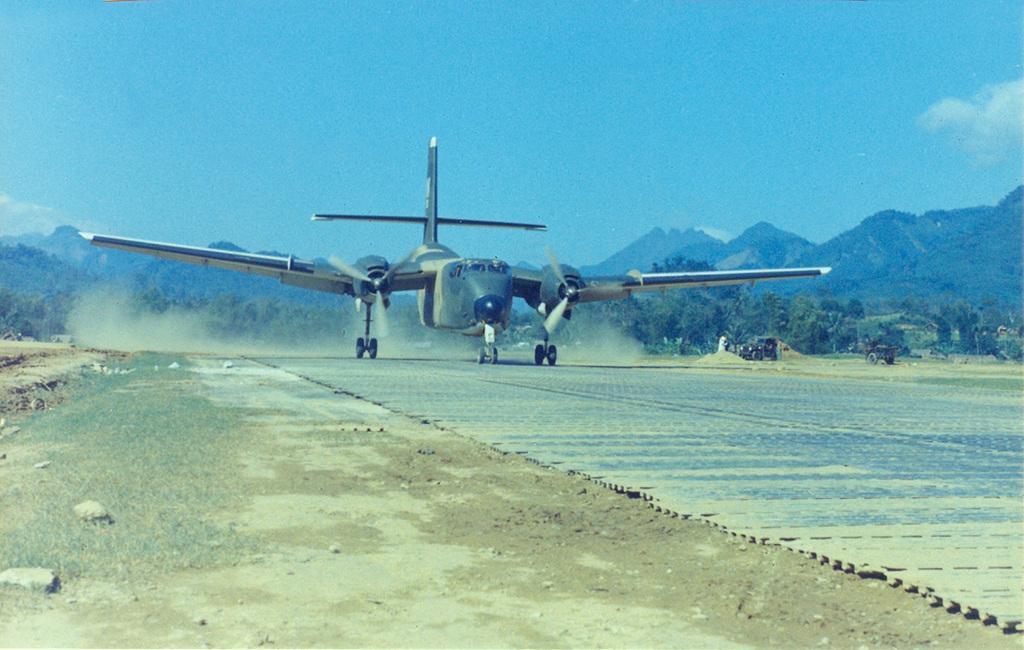Can you describe this image briefly? In this image there is a airplane is on the run way as we can see in the middle of this image. There are some trees and mountains in the background. There are some vehicles on the right side of this image. There is a blue sky on the top of this image. 